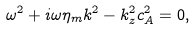<formula> <loc_0><loc_0><loc_500><loc_500>\omega ^ { 2 } + i \omega \eta _ { m } k ^ { 2 } - k _ { z } ^ { 2 } c _ { A } ^ { 2 } = 0 ,</formula> 